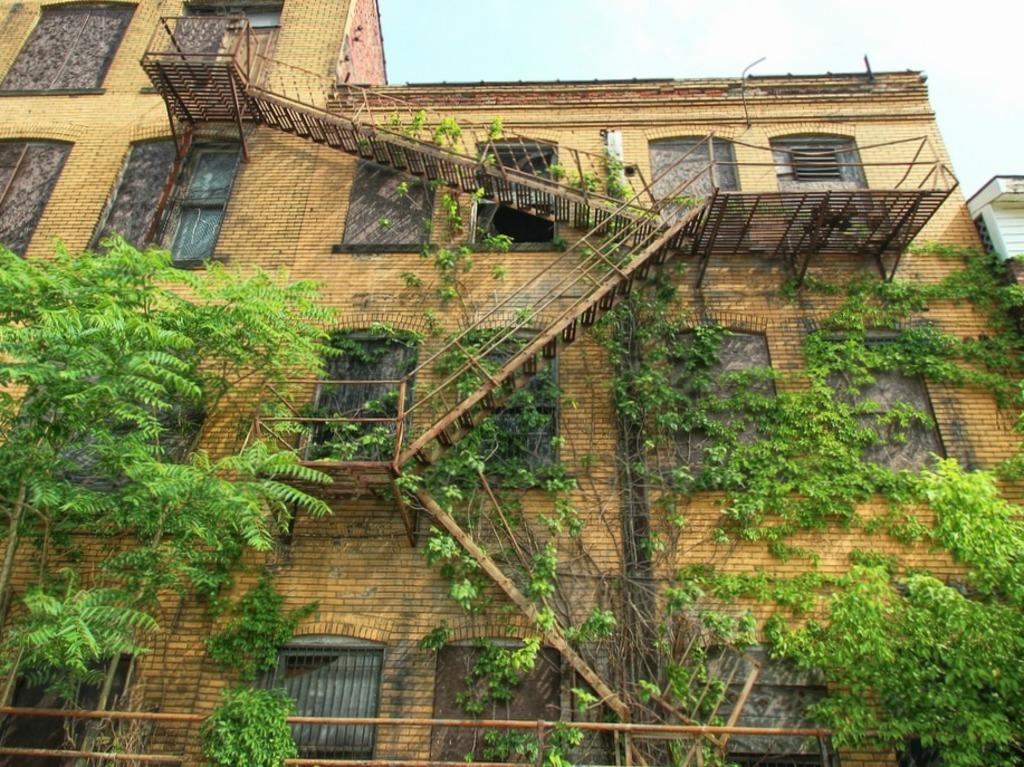What type of structure is present in the image? There is a building in the image. What natural elements can be seen in the image? There are trees in the image. What material is used for the rods visible in the image? Metal rods are visible in the image. What architectural feature is present in the image? There are steps in the image. What type of secretary can be seen working in the image? There is no secretary present in the image. What is the end result of the process depicted in the image? The image does not depict a process or an end result. Can you see any chickens in the image? There are no chickens present in the image. 